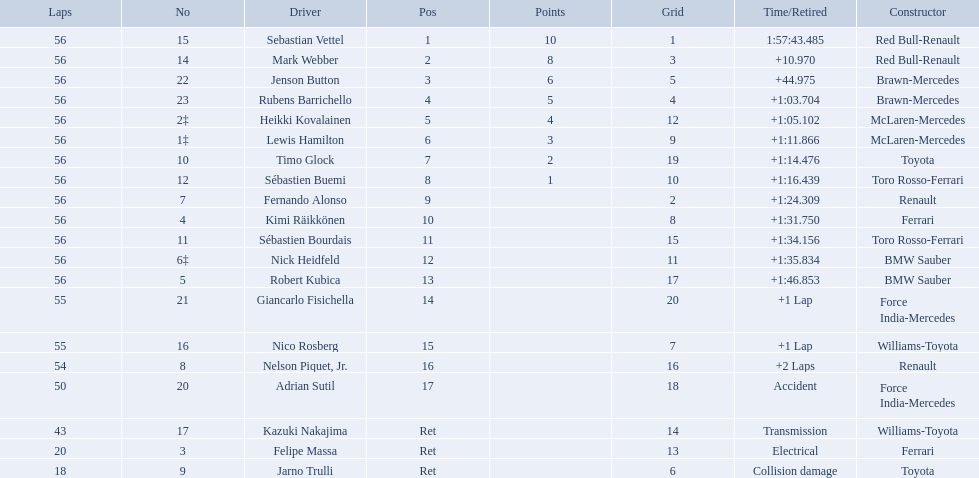Why did the  toyota retire Collision damage. Could you parse the entire table as a dict? {'header': ['Laps', 'No', 'Driver', 'Pos', 'Points', 'Grid', 'Time/Retired', 'Constructor'], 'rows': [['56', '15', 'Sebastian Vettel', '1', '10', '1', '1:57:43.485', 'Red Bull-Renault'], ['56', '14', 'Mark Webber', '2', '8', '3', '+10.970', 'Red Bull-Renault'], ['56', '22', 'Jenson Button', '3', '6', '5', '+44.975', 'Brawn-Mercedes'], ['56', '23', 'Rubens Barrichello', '4', '5', '4', '+1:03.704', 'Brawn-Mercedes'], ['56', '2‡', 'Heikki Kovalainen', '5', '4', '12', '+1:05.102', 'McLaren-Mercedes'], ['56', '1‡', 'Lewis Hamilton', '6', '3', '9', '+1:11.866', 'McLaren-Mercedes'], ['56', '10', 'Timo Glock', '7', '2', '19', '+1:14.476', 'Toyota'], ['56', '12', 'Sébastien Buemi', '8', '1', '10', '+1:16.439', 'Toro Rosso-Ferrari'], ['56', '7', 'Fernando Alonso', '9', '', '2', '+1:24.309', 'Renault'], ['56', '4', 'Kimi Räikkönen', '10', '', '8', '+1:31.750', 'Ferrari'], ['56', '11', 'Sébastien Bourdais', '11', '', '15', '+1:34.156', 'Toro Rosso-Ferrari'], ['56', '6‡', 'Nick Heidfeld', '12', '', '11', '+1:35.834', 'BMW Sauber'], ['56', '5', 'Robert Kubica', '13', '', '17', '+1:46.853', 'BMW Sauber'], ['55', '21', 'Giancarlo Fisichella', '14', '', '20', '+1 Lap', 'Force India-Mercedes'], ['55', '16', 'Nico Rosberg', '15', '', '7', '+1 Lap', 'Williams-Toyota'], ['54', '8', 'Nelson Piquet, Jr.', '16', '', '16', '+2 Laps', 'Renault'], ['50', '20', 'Adrian Sutil', '17', '', '18', 'Accident', 'Force India-Mercedes'], ['43', '17', 'Kazuki Nakajima', 'Ret', '', '14', 'Transmission', 'Williams-Toyota'], ['20', '3', 'Felipe Massa', 'Ret', '', '13', 'Electrical', 'Ferrari'], ['18', '9', 'Jarno Trulli', 'Ret', '', '6', 'Collision damage', 'Toyota']]} What was the drivers name? Jarno Trulli. Who are all the drivers? Sebastian Vettel, Mark Webber, Jenson Button, Rubens Barrichello, Heikki Kovalainen, Lewis Hamilton, Timo Glock, Sébastien Buemi, Fernando Alonso, Kimi Räikkönen, Sébastien Bourdais, Nick Heidfeld, Robert Kubica, Giancarlo Fisichella, Nico Rosberg, Nelson Piquet, Jr., Adrian Sutil, Kazuki Nakajima, Felipe Massa, Jarno Trulli. What were their finishing times? 1:57:43.485, +10.970, +44.975, +1:03.704, +1:05.102, +1:11.866, +1:14.476, +1:16.439, +1:24.309, +1:31.750, +1:34.156, +1:35.834, +1:46.853, +1 Lap, +1 Lap, +2 Laps, Accident, Transmission, Electrical, Collision damage. Who finished last? Robert Kubica. 